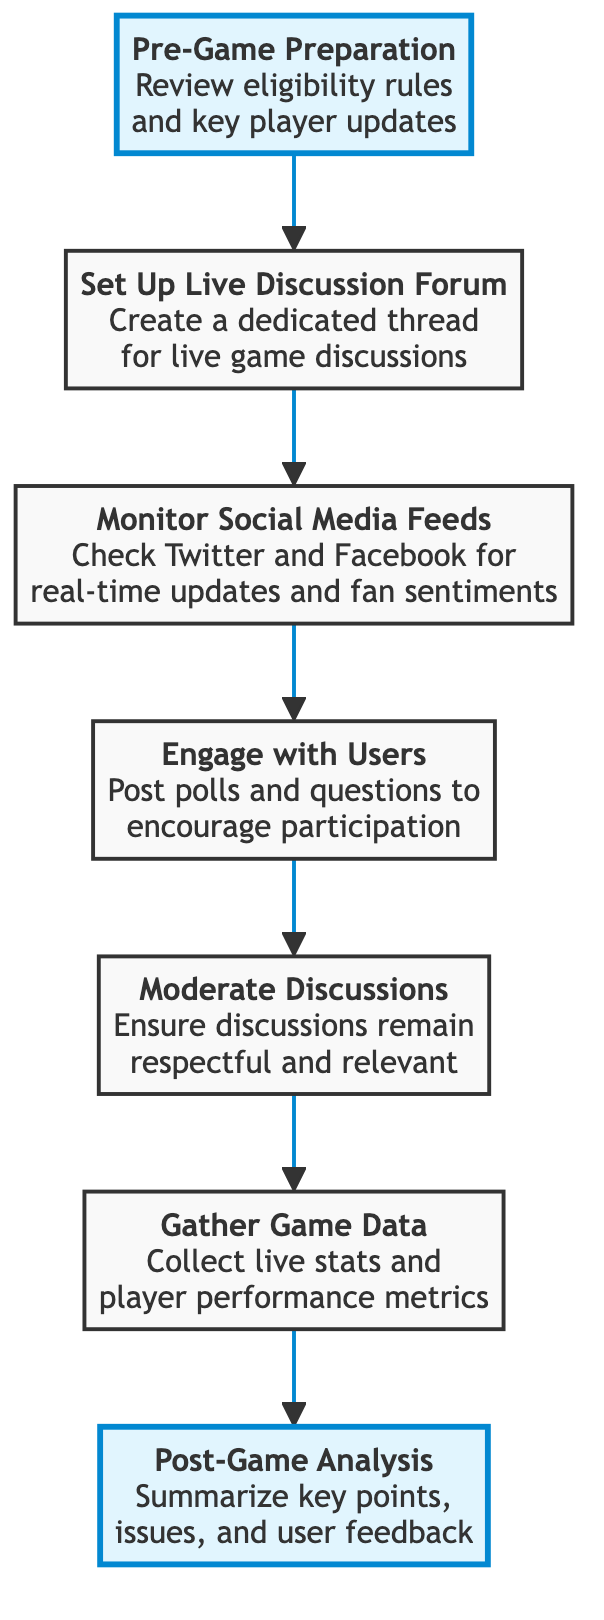What is the first step in the flow chart? The first step in the flow chart is labeled as "Pre-Game Preparation," which describes reviewing eligibility rules and key player updates.
Answer: Pre-Game Preparation How many nodes are there in the diagram? The diagram has a total of seven nodes, each representing a step in the flow of information on game day.
Answer: 7 What step comes after "Monitor Social Media Feeds"? After "Monitor Social Media Feeds," the next step is "Engage with Users," where interactions such as posting polls and questions take place.
Answer: Engage with Users What is the last step of the flow? The last step of the flow chart is "Post-Game Analysis," which involves summarizing key points, issues, and user feedback after the game has concluded.
Answer: Post-Game Analysis Which step involves social media interaction? The step that involves social media interaction is "Monitor Social Media Feeds," where Twitter and Facebook are checked for updates and sentiments.
Answer: Monitor Social Media Feeds How many arrows connect the nodes in the flow chart? There are six arrows connecting the seven nodes in the flow chart, illustrating the progression from one step to the next.
Answer: 6 What is the purpose of the "Gather Game Data" step? The purpose of the "Gather Game Data" step is to collect live stats and player performance metrics during the game.
Answer: Collect live stats and player performance metrics What is the focus of the "Engage with Users" step? The focus of the "Engage with Users" step is to post polls and questions to encourage user participation in the live discussion.
Answer: Post polls and questions What precedes "Moderate Discussions"? The step that precedes "Moderate Discussions" is "Engage with Users," which involves encouraging participation before ensuring discussions are respectful.
Answer: Engage with Users 